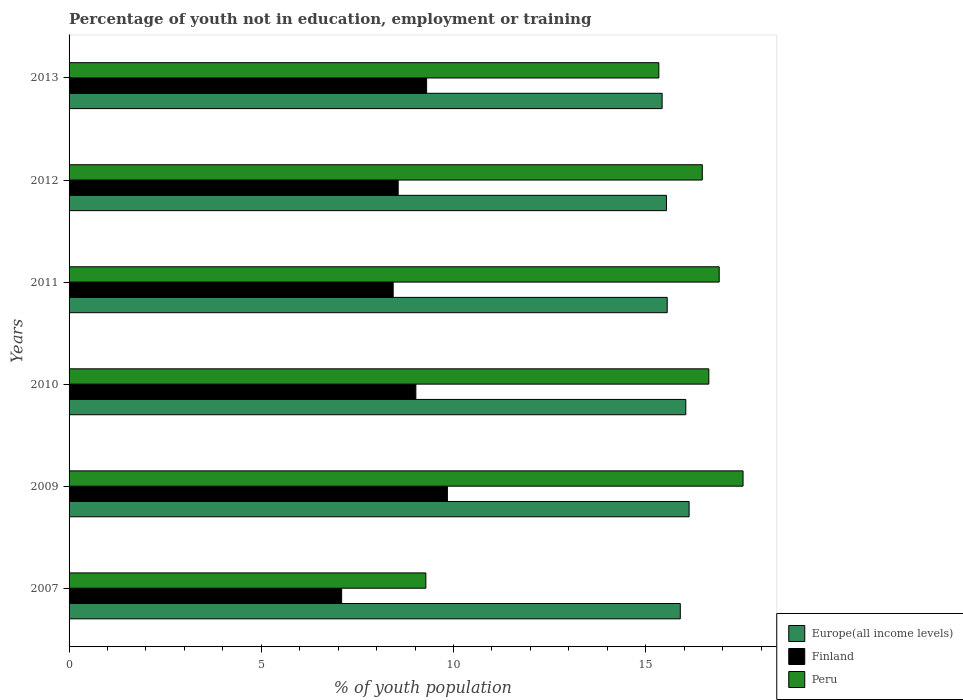How many groups of bars are there?
Your response must be concise. 6. Are the number of bars on each tick of the Y-axis equal?
Offer a terse response. Yes. How many bars are there on the 6th tick from the top?
Keep it short and to the point. 3. How many bars are there on the 1st tick from the bottom?
Offer a terse response. 3. In how many cases, is the number of bars for a given year not equal to the number of legend labels?
Keep it short and to the point. 0. What is the percentage of unemployed youth population in in Finland in 2007?
Offer a very short reply. 7.09. Across all years, what is the maximum percentage of unemployed youth population in in Finland?
Provide a succinct answer. 9.84. Across all years, what is the minimum percentage of unemployed youth population in in Finland?
Keep it short and to the point. 7.09. In which year was the percentage of unemployed youth population in in Finland maximum?
Keep it short and to the point. 2009. In which year was the percentage of unemployed youth population in in Europe(all income levels) minimum?
Make the answer very short. 2013. What is the total percentage of unemployed youth population in in Finland in the graph?
Your answer should be compact. 52.24. What is the difference between the percentage of unemployed youth population in in Europe(all income levels) in 2009 and that in 2011?
Ensure brevity in your answer.  0.57. What is the difference between the percentage of unemployed youth population in in Peru in 2010 and the percentage of unemployed youth population in in Europe(all income levels) in 2013?
Ensure brevity in your answer.  1.21. What is the average percentage of unemployed youth population in in Finland per year?
Your answer should be very brief. 8.71. In the year 2011, what is the difference between the percentage of unemployed youth population in in Europe(all income levels) and percentage of unemployed youth population in in Peru?
Offer a very short reply. -1.35. What is the ratio of the percentage of unemployed youth population in in Peru in 2009 to that in 2013?
Offer a terse response. 1.14. Is the percentage of unemployed youth population in in Finland in 2007 less than that in 2010?
Your answer should be very brief. Yes. What is the difference between the highest and the second highest percentage of unemployed youth population in in Europe(all income levels)?
Offer a terse response. 0.09. What is the difference between the highest and the lowest percentage of unemployed youth population in in Peru?
Provide a short and direct response. 8.25. Is the sum of the percentage of unemployed youth population in in Finland in 2009 and 2012 greater than the maximum percentage of unemployed youth population in in Peru across all years?
Keep it short and to the point. Yes. What does the 2nd bar from the top in 2013 represents?
Give a very brief answer. Finland. What does the 1st bar from the bottom in 2011 represents?
Provide a short and direct response. Europe(all income levels). Is it the case that in every year, the sum of the percentage of unemployed youth population in in Finland and percentage of unemployed youth population in in Europe(all income levels) is greater than the percentage of unemployed youth population in in Peru?
Your response must be concise. Yes. How many bars are there?
Your response must be concise. 18. Are all the bars in the graph horizontal?
Ensure brevity in your answer.  Yes. What is the difference between two consecutive major ticks on the X-axis?
Your answer should be compact. 5. Are the values on the major ticks of X-axis written in scientific E-notation?
Your answer should be very brief. No. Does the graph contain any zero values?
Provide a short and direct response. No. Does the graph contain grids?
Offer a very short reply. No. How are the legend labels stacked?
Offer a terse response. Vertical. What is the title of the graph?
Keep it short and to the point. Percentage of youth not in education, employment or training. Does "New Caledonia" appear as one of the legend labels in the graph?
Your answer should be very brief. No. What is the label or title of the X-axis?
Offer a terse response. % of youth population. What is the label or title of the Y-axis?
Give a very brief answer. Years. What is the % of youth population of Europe(all income levels) in 2007?
Offer a very short reply. 15.9. What is the % of youth population in Finland in 2007?
Your response must be concise. 7.09. What is the % of youth population of Peru in 2007?
Keep it short and to the point. 9.28. What is the % of youth population in Europe(all income levels) in 2009?
Your answer should be compact. 16.13. What is the % of youth population in Finland in 2009?
Provide a succinct answer. 9.84. What is the % of youth population in Peru in 2009?
Give a very brief answer. 17.53. What is the % of youth population of Europe(all income levels) in 2010?
Make the answer very short. 16.04. What is the % of youth population in Finland in 2010?
Provide a short and direct response. 9.02. What is the % of youth population of Peru in 2010?
Provide a succinct answer. 16.64. What is the % of youth population in Europe(all income levels) in 2011?
Your response must be concise. 15.56. What is the % of youth population of Finland in 2011?
Ensure brevity in your answer.  8.43. What is the % of youth population of Peru in 2011?
Your answer should be very brief. 16.91. What is the % of youth population of Europe(all income levels) in 2012?
Give a very brief answer. 15.54. What is the % of youth population of Finland in 2012?
Provide a succinct answer. 8.56. What is the % of youth population in Peru in 2012?
Offer a very short reply. 16.47. What is the % of youth population of Europe(all income levels) in 2013?
Your response must be concise. 15.43. What is the % of youth population in Finland in 2013?
Make the answer very short. 9.3. What is the % of youth population in Peru in 2013?
Offer a very short reply. 15.34. Across all years, what is the maximum % of youth population in Europe(all income levels)?
Provide a succinct answer. 16.13. Across all years, what is the maximum % of youth population in Finland?
Your answer should be very brief. 9.84. Across all years, what is the maximum % of youth population of Peru?
Offer a very short reply. 17.53. Across all years, what is the minimum % of youth population in Europe(all income levels)?
Your response must be concise. 15.43. Across all years, what is the minimum % of youth population of Finland?
Your answer should be very brief. 7.09. Across all years, what is the minimum % of youth population of Peru?
Keep it short and to the point. 9.28. What is the total % of youth population of Europe(all income levels) in the graph?
Your answer should be very brief. 94.59. What is the total % of youth population of Finland in the graph?
Make the answer very short. 52.24. What is the total % of youth population in Peru in the graph?
Give a very brief answer. 92.17. What is the difference between the % of youth population of Europe(all income levels) in 2007 and that in 2009?
Your answer should be compact. -0.23. What is the difference between the % of youth population in Finland in 2007 and that in 2009?
Offer a very short reply. -2.75. What is the difference between the % of youth population of Peru in 2007 and that in 2009?
Give a very brief answer. -8.25. What is the difference between the % of youth population in Europe(all income levels) in 2007 and that in 2010?
Provide a short and direct response. -0.14. What is the difference between the % of youth population in Finland in 2007 and that in 2010?
Your answer should be very brief. -1.93. What is the difference between the % of youth population in Peru in 2007 and that in 2010?
Provide a succinct answer. -7.36. What is the difference between the % of youth population of Europe(all income levels) in 2007 and that in 2011?
Offer a terse response. 0.34. What is the difference between the % of youth population of Finland in 2007 and that in 2011?
Provide a succinct answer. -1.34. What is the difference between the % of youth population of Peru in 2007 and that in 2011?
Keep it short and to the point. -7.63. What is the difference between the % of youth population in Europe(all income levels) in 2007 and that in 2012?
Your answer should be very brief. 0.36. What is the difference between the % of youth population of Finland in 2007 and that in 2012?
Your response must be concise. -1.47. What is the difference between the % of youth population of Peru in 2007 and that in 2012?
Keep it short and to the point. -7.19. What is the difference between the % of youth population of Europe(all income levels) in 2007 and that in 2013?
Your answer should be compact. 0.47. What is the difference between the % of youth population in Finland in 2007 and that in 2013?
Ensure brevity in your answer.  -2.21. What is the difference between the % of youth population of Peru in 2007 and that in 2013?
Provide a short and direct response. -6.06. What is the difference between the % of youth population in Europe(all income levels) in 2009 and that in 2010?
Provide a succinct answer. 0.09. What is the difference between the % of youth population in Finland in 2009 and that in 2010?
Offer a terse response. 0.82. What is the difference between the % of youth population in Peru in 2009 and that in 2010?
Offer a terse response. 0.89. What is the difference between the % of youth population of Europe(all income levels) in 2009 and that in 2011?
Your response must be concise. 0.57. What is the difference between the % of youth population of Finland in 2009 and that in 2011?
Make the answer very short. 1.41. What is the difference between the % of youth population in Peru in 2009 and that in 2011?
Make the answer very short. 0.62. What is the difference between the % of youth population in Europe(all income levels) in 2009 and that in 2012?
Provide a succinct answer. 0.59. What is the difference between the % of youth population in Finland in 2009 and that in 2012?
Offer a very short reply. 1.28. What is the difference between the % of youth population of Peru in 2009 and that in 2012?
Ensure brevity in your answer.  1.06. What is the difference between the % of youth population of Europe(all income levels) in 2009 and that in 2013?
Make the answer very short. 0.7. What is the difference between the % of youth population in Finland in 2009 and that in 2013?
Your answer should be very brief. 0.54. What is the difference between the % of youth population of Peru in 2009 and that in 2013?
Provide a short and direct response. 2.19. What is the difference between the % of youth population of Europe(all income levels) in 2010 and that in 2011?
Ensure brevity in your answer.  0.48. What is the difference between the % of youth population of Finland in 2010 and that in 2011?
Give a very brief answer. 0.59. What is the difference between the % of youth population of Peru in 2010 and that in 2011?
Your answer should be compact. -0.27. What is the difference between the % of youth population of Europe(all income levels) in 2010 and that in 2012?
Your answer should be compact. 0.5. What is the difference between the % of youth population of Finland in 2010 and that in 2012?
Ensure brevity in your answer.  0.46. What is the difference between the % of youth population in Peru in 2010 and that in 2012?
Offer a very short reply. 0.17. What is the difference between the % of youth population in Europe(all income levels) in 2010 and that in 2013?
Make the answer very short. 0.62. What is the difference between the % of youth population of Finland in 2010 and that in 2013?
Offer a terse response. -0.28. What is the difference between the % of youth population of Peru in 2010 and that in 2013?
Offer a terse response. 1.3. What is the difference between the % of youth population of Europe(all income levels) in 2011 and that in 2012?
Give a very brief answer. 0.02. What is the difference between the % of youth population of Finland in 2011 and that in 2012?
Your response must be concise. -0.13. What is the difference between the % of youth population in Peru in 2011 and that in 2012?
Offer a terse response. 0.44. What is the difference between the % of youth population in Europe(all income levels) in 2011 and that in 2013?
Ensure brevity in your answer.  0.13. What is the difference between the % of youth population of Finland in 2011 and that in 2013?
Offer a terse response. -0.87. What is the difference between the % of youth population of Peru in 2011 and that in 2013?
Your response must be concise. 1.57. What is the difference between the % of youth population of Europe(all income levels) in 2012 and that in 2013?
Offer a very short reply. 0.11. What is the difference between the % of youth population of Finland in 2012 and that in 2013?
Keep it short and to the point. -0.74. What is the difference between the % of youth population of Peru in 2012 and that in 2013?
Your answer should be compact. 1.13. What is the difference between the % of youth population of Europe(all income levels) in 2007 and the % of youth population of Finland in 2009?
Your response must be concise. 6.06. What is the difference between the % of youth population in Europe(all income levels) in 2007 and the % of youth population in Peru in 2009?
Provide a succinct answer. -1.63. What is the difference between the % of youth population in Finland in 2007 and the % of youth population in Peru in 2009?
Provide a short and direct response. -10.44. What is the difference between the % of youth population of Europe(all income levels) in 2007 and the % of youth population of Finland in 2010?
Your answer should be compact. 6.88. What is the difference between the % of youth population in Europe(all income levels) in 2007 and the % of youth population in Peru in 2010?
Keep it short and to the point. -0.74. What is the difference between the % of youth population of Finland in 2007 and the % of youth population of Peru in 2010?
Offer a very short reply. -9.55. What is the difference between the % of youth population in Europe(all income levels) in 2007 and the % of youth population in Finland in 2011?
Provide a succinct answer. 7.47. What is the difference between the % of youth population in Europe(all income levels) in 2007 and the % of youth population in Peru in 2011?
Your answer should be very brief. -1.01. What is the difference between the % of youth population of Finland in 2007 and the % of youth population of Peru in 2011?
Your response must be concise. -9.82. What is the difference between the % of youth population of Europe(all income levels) in 2007 and the % of youth population of Finland in 2012?
Your response must be concise. 7.34. What is the difference between the % of youth population of Europe(all income levels) in 2007 and the % of youth population of Peru in 2012?
Provide a short and direct response. -0.57. What is the difference between the % of youth population in Finland in 2007 and the % of youth population in Peru in 2012?
Your answer should be very brief. -9.38. What is the difference between the % of youth population of Europe(all income levels) in 2007 and the % of youth population of Finland in 2013?
Provide a short and direct response. 6.6. What is the difference between the % of youth population of Europe(all income levels) in 2007 and the % of youth population of Peru in 2013?
Ensure brevity in your answer.  0.56. What is the difference between the % of youth population in Finland in 2007 and the % of youth population in Peru in 2013?
Your response must be concise. -8.25. What is the difference between the % of youth population of Europe(all income levels) in 2009 and the % of youth population of Finland in 2010?
Ensure brevity in your answer.  7.11. What is the difference between the % of youth population of Europe(all income levels) in 2009 and the % of youth population of Peru in 2010?
Make the answer very short. -0.51. What is the difference between the % of youth population in Europe(all income levels) in 2009 and the % of youth population in Finland in 2011?
Your answer should be compact. 7.7. What is the difference between the % of youth population in Europe(all income levels) in 2009 and the % of youth population in Peru in 2011?
Provide a short and direct response. -0.78. What is the difference between the % of youth population of Finland in 2009 and the % of youth population of Peru in 2011?
Make the answer very short. -7.07. What is the difference between the % of youth population in Europe(all income levels) in 2009 and the % of youth population in Finland in 2012?
Keep it short and to the point. 7.57. What is the difference between the % of youth population of Europe(all income levels) in 2009 and the % of youth population of Peru in 2012?
Provide a short and direct response. -0.34. What is the difference between the % of youth population of Finland in 2009 and the % of youth population of Peru in 2012?
Provide a succinct answer. -6.63. What is the difference between the % of youth population of Europe(all income levels) in 2009 and the % of youth population of Finland in 2013?
Make the answer very short. 6.83. What is the difference between the % of youth population of Europe(all income levels) in 2009 and the % of youth population of Peru in 2013?
Keep it short and to the point. 0.79. What is the difference between the % of youth population of Finland in 2009 and the % of youth population of Peru in 2013?
Make the answer very short. -5.5. What is the difference between the % of youth population in Europe(all income levels) in 2010 and the % of youth population in Finland in 2011?
Provide a succinct answer. 7.61. What is the difference between the % of youth population in Europe(all income levels) in 2010 and the % of youth population in Peru in 2011?
Offer a very short reply. -0.87. What is the difference between the % of youth population in Finland in 2010 and the % of youth population in Peru in 2011?
Provide a short and direct response. -7.89. What is the difference between the % of youth population of Europe(all income levels) in 2010 and the % of youth population of Finland in 2012?
Provide a succinct answer. 7.48. What is the difference between the % of youth population of Europe(all income levels) in 2010 and the % of youth population of Peru in 2012?
Provide a short and direct response. -0.43. What is the difference between the % of youth population in Finland in 2010 and the % of youth population in Peru in 2012?
Offer a terse response. -7.45. What is the difference between the % of youth population of Europe(all income levels) in 2010 and the % of youth population of Finland in 2013?
Your answer should be compact. 6.74. What is the difference between the % of youth population in Europe(all income levels) in 2010 and the % of youth population in Peru in 2013?
Your response must be concise. 0.7. What is the difference between the % of youth population of Finland in 2010 and the % of youth population of Peru in 2013?
Make the answer very short. -6.32. What is the difference between the % of youth population of Europe(all income levels) in 2011 and the % of youth population of Finland in 2012?
Offer a terse response. 7. What is the difference between the % of youth population in Europe(all income levels) in 2011 and the % of youth population in Peru in 2012?
Keep it short and to the point. -0.91. What is the difference between the % of youth population in Finland in 2011 and the % of youth population in Peru in 2012?
Ensure brevity in your answer.  -8.04. What is the difference between the % of youth population in Europe(all income levels) in 2011 and the % of youth population in Finland in 2013?
Your answer should be very brief. 6.26. What is the difference between the % of youth population in Europe(all income levels) in 2011 and the % of youth population in Peru in 2013?
Your answer should be very brief. 0.22. What is the difference between the % of youth population of Finland in 2011 and the % of youth population of Peru in 2013?
Your answer should be very brief. -6.91. What is the difference between the % of youth population in Europe(all income levels) in 2012 and the % of youth population in Finland in 2013?
Offer a very short reply. 6.24. What is the difference between the % of youth population in Europe(all income levels) in 2012 and the % of youth population in Peru in 2013?
Provide a short and direct response. 0.2. What is the difference between the % of youth population of Finland in 2012 and the % of youth population of Peru in 2013?
Your response must be concise. -6.78. What is the average % of youth population of Europe(all income levels) per year?
Ensure brevity in your answer.  15.76. What is the average % of youth population in Finland per year?
Your answer should be compact. 8.71. What is the average % of youth population of Peru per year?
Offer a terse response. 15.36. In the year 2007, what is the difference between the % of youth population in Europe(all income levels) and % of youth population in Finland?
Make the answer very short. 8.81. In the year 2007, what is the difference between the % of youth population of Europe(all income levels) and % of youth population of Peru?
Ensure brevity in your answer.  6.62. In the year 2007, what is the difference between the % of youth population in Finland and % of youth population in Peru?
Keep it short and to the point. -2.19. In the year 2009, what is the difference between the % of youth population in Europe(all income levels) and % of youth population in Finland?
Your response must be concise. 6.29. In the year 2009, what is the difference between the % of youth population of Europe(all income levels) and % of youth population of Peru?
Your response must be concise. -1.4. In the year 2009, what is the difference between the % of youth population of Finland and % of youth population of Peru?
Your answer should be very brief. -7.69. In the year 2010, what is the difference between the % of youth population of Europe(all income levels) and % of youth population of Finland?
Your answer should be very brief. 7.02. In the year 2010, what is the difference between the % of youth population of Europe(all income levels) and % of youth population of Peru?
Offer a terse response. -0.6. In the year 2010, what is the difference between the % of youth population of Finland and % of youth population of Peru?
Provide a short and direct response. -7.62. In the year 2011, what is the difference between the % of youth population in Europe(all income levels) and % of youth population in Finland?
Your answer should be very brief. 7.13. In the year 2011, what is the difference between the % of youth population of Europe(all income levels) and % of youth population of Peru?
Your answer should be compact. -1.35. In the year 2011, what is the difference between the % of youth population of Finland and % of youth population of Peru?
Your answer should be compact. -8.48. In the year 2012, what is the difference between the % of youth population in Europe(all income levels) and % of youth population in Finland?
Your response must be concise. 6.98. In the year 2012, what is the difference between the % of youth population in Europe(all income levels) and % of youth population in Peru?
Provide a succinct answer. -0.93. In the year 2012, what is the difference between the % of youth population in Finland and % of youth population in Peru?
Your answer should be compact. -7.91. In the year 2013, what is the difference between the % of youth population in Europe(all income levels) and % of youth population in Finland?
Give a very brief answer. 6.13. In the year 2013, what is the difference between the % of youth population in Europe(all income levels) and % of youth population in Peru?
Provide a succinct answer. 0.09. In the year 2013, what is the difference between the % of youth population in Finland and % of youth population in Peru?
Give a very brief answer. -6.04. What is the ratio of the % of youth population in Europe(all income levels) in 2007 to that in 2009?
Your response must be concise. 0.99. What is the ratio of the % of youth population of Finland in 2007 to that in 2009?
Give a very brief answer. 0.72. What is the ratio of the % of youth population of Peru in 2007 to that in 2009?
Your answer should be very brief. 0.53. What is the ratio of the % of youth population in Finland in 2007 to that in 2010?
Provide a succinct answer. 0.79. What is the ratio of the % of youth population in Peru in 2007 to that in 2010?
Offer a terse response. 0.56. What is the ratio of the % of youth population in Europe(all income levels) in 2007 to that in 2011?
Provide a short and direct response. 1.02. What is the ratio of the % of youth population of Finland in 2007 to that in 2011?
Provide a short and direct response. 0.84. What is the ratio of the % of youth population of Peru in 2007 to that in 2011?
Make the answer very short. 0.55. What is the ratio of the % of youth population of Europe(all income levels) in 2007 to that in 2012?
Keep it short and to the point. 1.02. What is the ratio of the % of youth population in Finland in 2007 to that in 2012?
Your answer should be very brief. 0.83. What is the ratio of the % of youth population in Peru in 2007 to that in 2012?
Offer a very short reply. 0.56. What is the ratio of the % of youth population of Europe(all income levels) in 2007 to that in 2013?
Your answer should be compact. 1.03. What is the ratio of the % of youth population of Finland in 2007 to that in 2013?
Make the answer very short. 0.76. What is the ratio of the % of youth population in Peru in 2007 to that in 2013?
Give a very brief answer. 0.6. What is the ratio of the % of youth population in Peru in 2009 to that in 2010?
Your response must be concise. 1.05. What is the ratio of the % of youth population in Europe(all income levels) in 2009 to that in 2011?
Your response must be concise. 1.04. What is the ratio of the % of youth population of Finland in 2009 to that in 2011?
Your answer should be compact. 1.17. What is the ratio of the % of youth population of Peru in 2009 to that in 2011?
Make the answer very short. 1.04. What is the ratio of the % of youth population in Europe(all income levels) in 2009 to that in 2012?
Your response must be concise. 1.04. What is the ratio of the % of youth population in Finland in 2009 to that in 2012?
Offer a very short reply. 1.15. What is the ratio of the % of youth population in Peru in 2009 to that in 2012?
Your answer should be very brief. 1.06. What is the ratio of the % of youth population of Europe(all income levels) in 2009 to that in 2013?
Ensure brevity in your answer.  1.05. What is the ratio of the % of youth population in Finland in 2009 to that in 2013?
Your answer should be compact. 1.06. What is the ratio of the % of youth population in Peru in 2009 to that in 2013?
Offer a terse response. 1.14. What is the ratio of the % of youth population of Europe(all income levels) in 2010 to that in 2011?
Your response must be concise. 1.03. What is the ratio of the % of youth population in Finland in 2010 to that in 2011?
Your answer should be very brief. 1.07. What is the ratio of the % of youth population in Peru in 2010 to that in 2011?
Your response must be concise. 0.98. What is the ratio of the % of youth population of Europe(all income levels) in 2010 to that in 2012?
Your answer should be very brief. 1.03. What is the ratio of the % of youth population of Finland in 2010 to that in 2012?
Give a very brief answer. 1.05. What is the ratio of the % of youth population in Peru in 2010 to that in 2012?
Your response must be concise. 1.01. What is the ratio of the % of youth population of Europe(all income levels) in 2010 to that in 2013?
Make the answer very short. 1.04. What is the ratio of the % of youth population of Finland in 2010 to that in 2013?
Ensure brevity in your answer.  0.97. What is the ratio of the % of youth population in Peru in 2010 to that in 2013?
Give a very brief answer. 1.08. What is the ratio of the % of youth population in Peru in 2011 to that in 2012?
Give a very brief answer. 1.03. What is the ratio of the % of youth population of Europe(all income levels) in 2011 to that in 2013?
Make the answer very short. 1.01. What is the ratio of the % of youth population of Finland in 2011 to that in 2013?
Your answer should be compact. 0.91. What is the ratio of the % of youth population of Peru in 2011 to that in 2013?
Your answer should be very brief. 1.1. What is the ratio of the % of youth population in Europe(all income levels) in 2012 to that in 2013?
Offer a terse response. 1.01. What is the ratio of the % of youth population of Finland in 2012 to that in 2013?
Make the answer very short. 0.92. What is the ratio of the % of youth population of Peru in 2012 to that in 2013?
Ensure brevity in your answer.  1.07. What is the difference between the highest and the second highest % of youth population in Europe(all income levels)?
Offer a terse response. 0.09. What is the difference between the highest and the second highest % of youth population of Finland?
Give a very brief answer. 0.54. What is the difference between the highest and the second highest % of youth population in Peru?
Your answer should be very brief. 0.62. What is the difference between the highest and the lowest % of youth population in Europe(all income levels)?
Give a very brief answer. 0.7. What is the difference between the highest and the lowest % of youth population of Finland?
Give a very brief answer. 2.75. What is the difference between the highest and the lowest % of youth population in Peru?
Your answer should be compact. 8.25. 